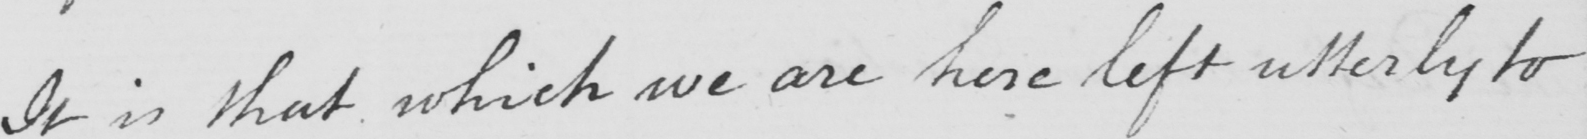What does this handwritten line say? It is that which we are here left utterly to 